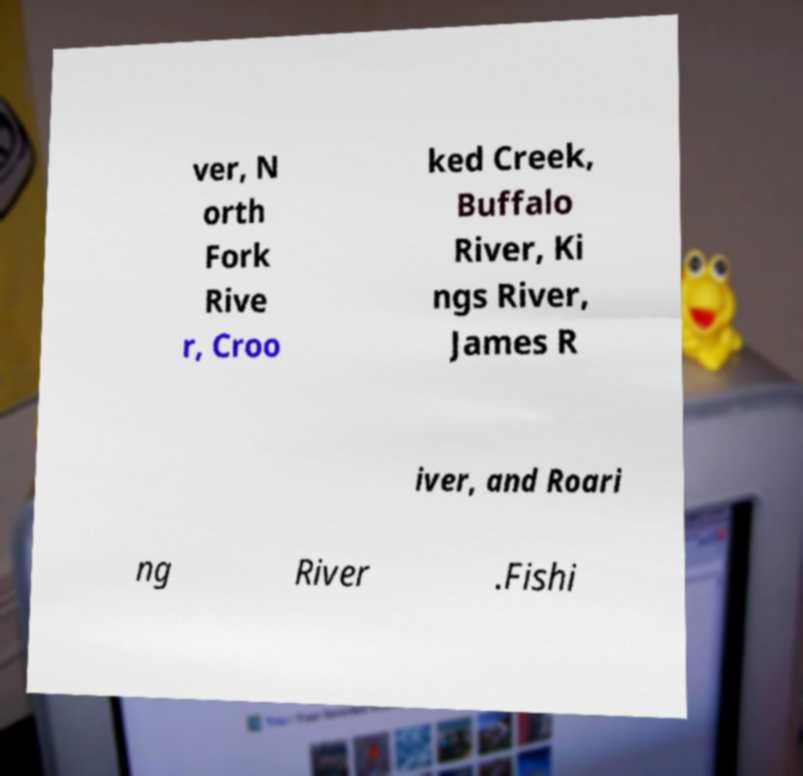What messages or text are displayed in this image? I need them in a readable, typed format. ver, N orth Fork Rive r, Croo ked Creek, Buffalo River, Ki ngs River, James R iver, and Roari ng River .Fishi 